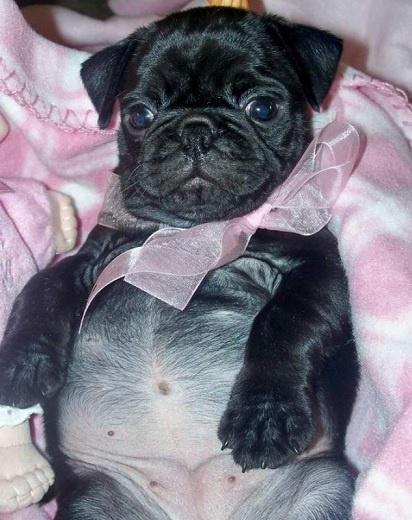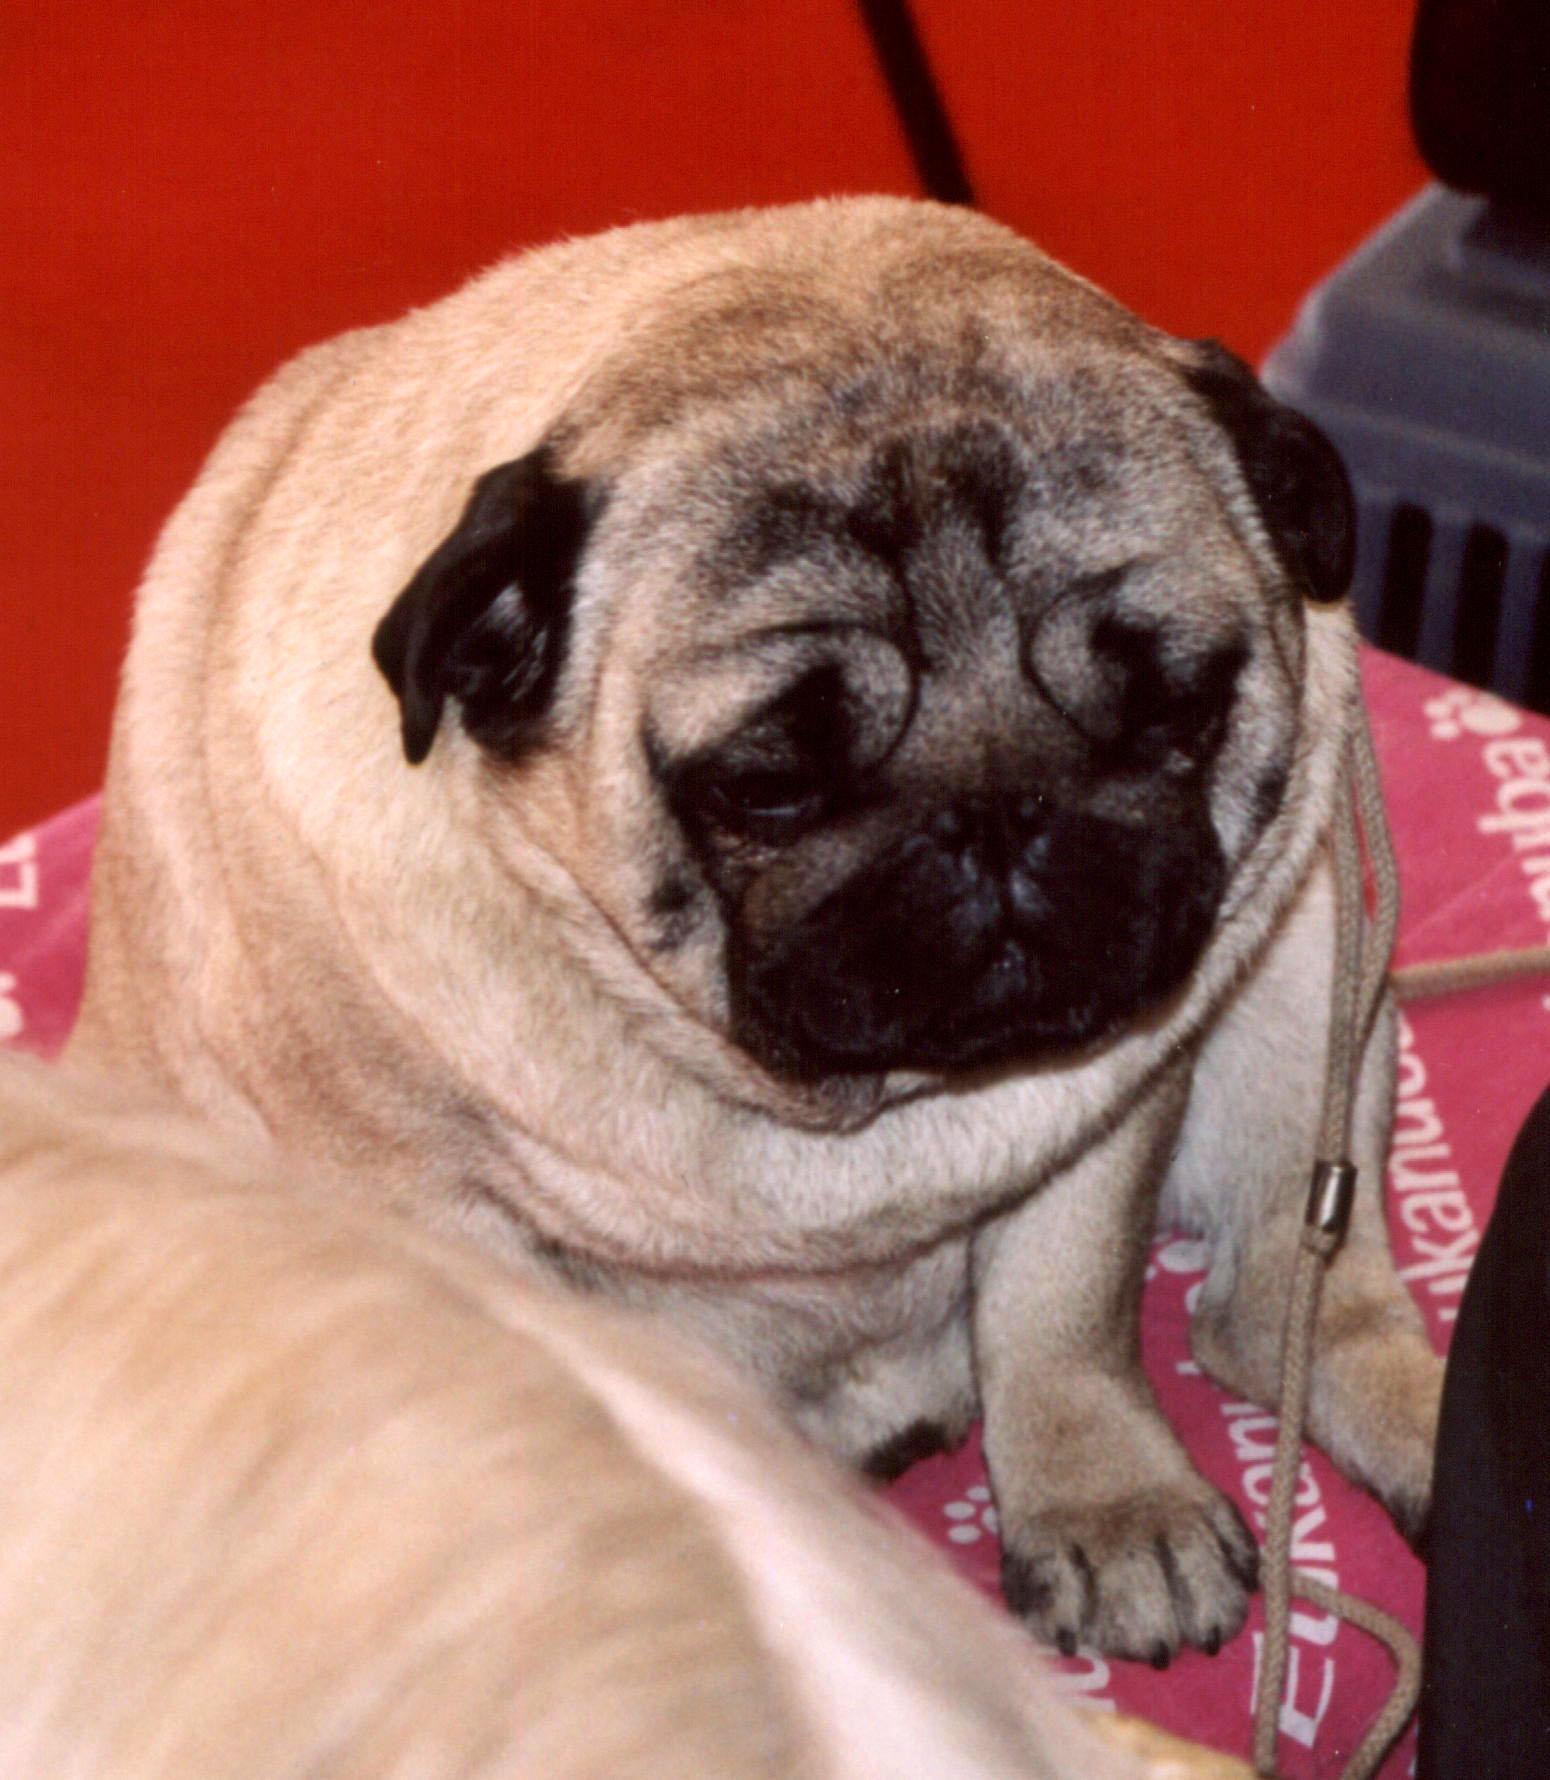The first image is the image on the left, the second image is the image on the right. Examine the images to the left and right. Is the description "There is a pug lying on its back in the left image." accurate? Answer yes or no. Yes. The first image is the image on the left, the second image is the image on the right. Evaluate the accuracy of this statement regarding the images: "A dog is wearing an accessory.". Is it true? Answer yes or no. Yes. 